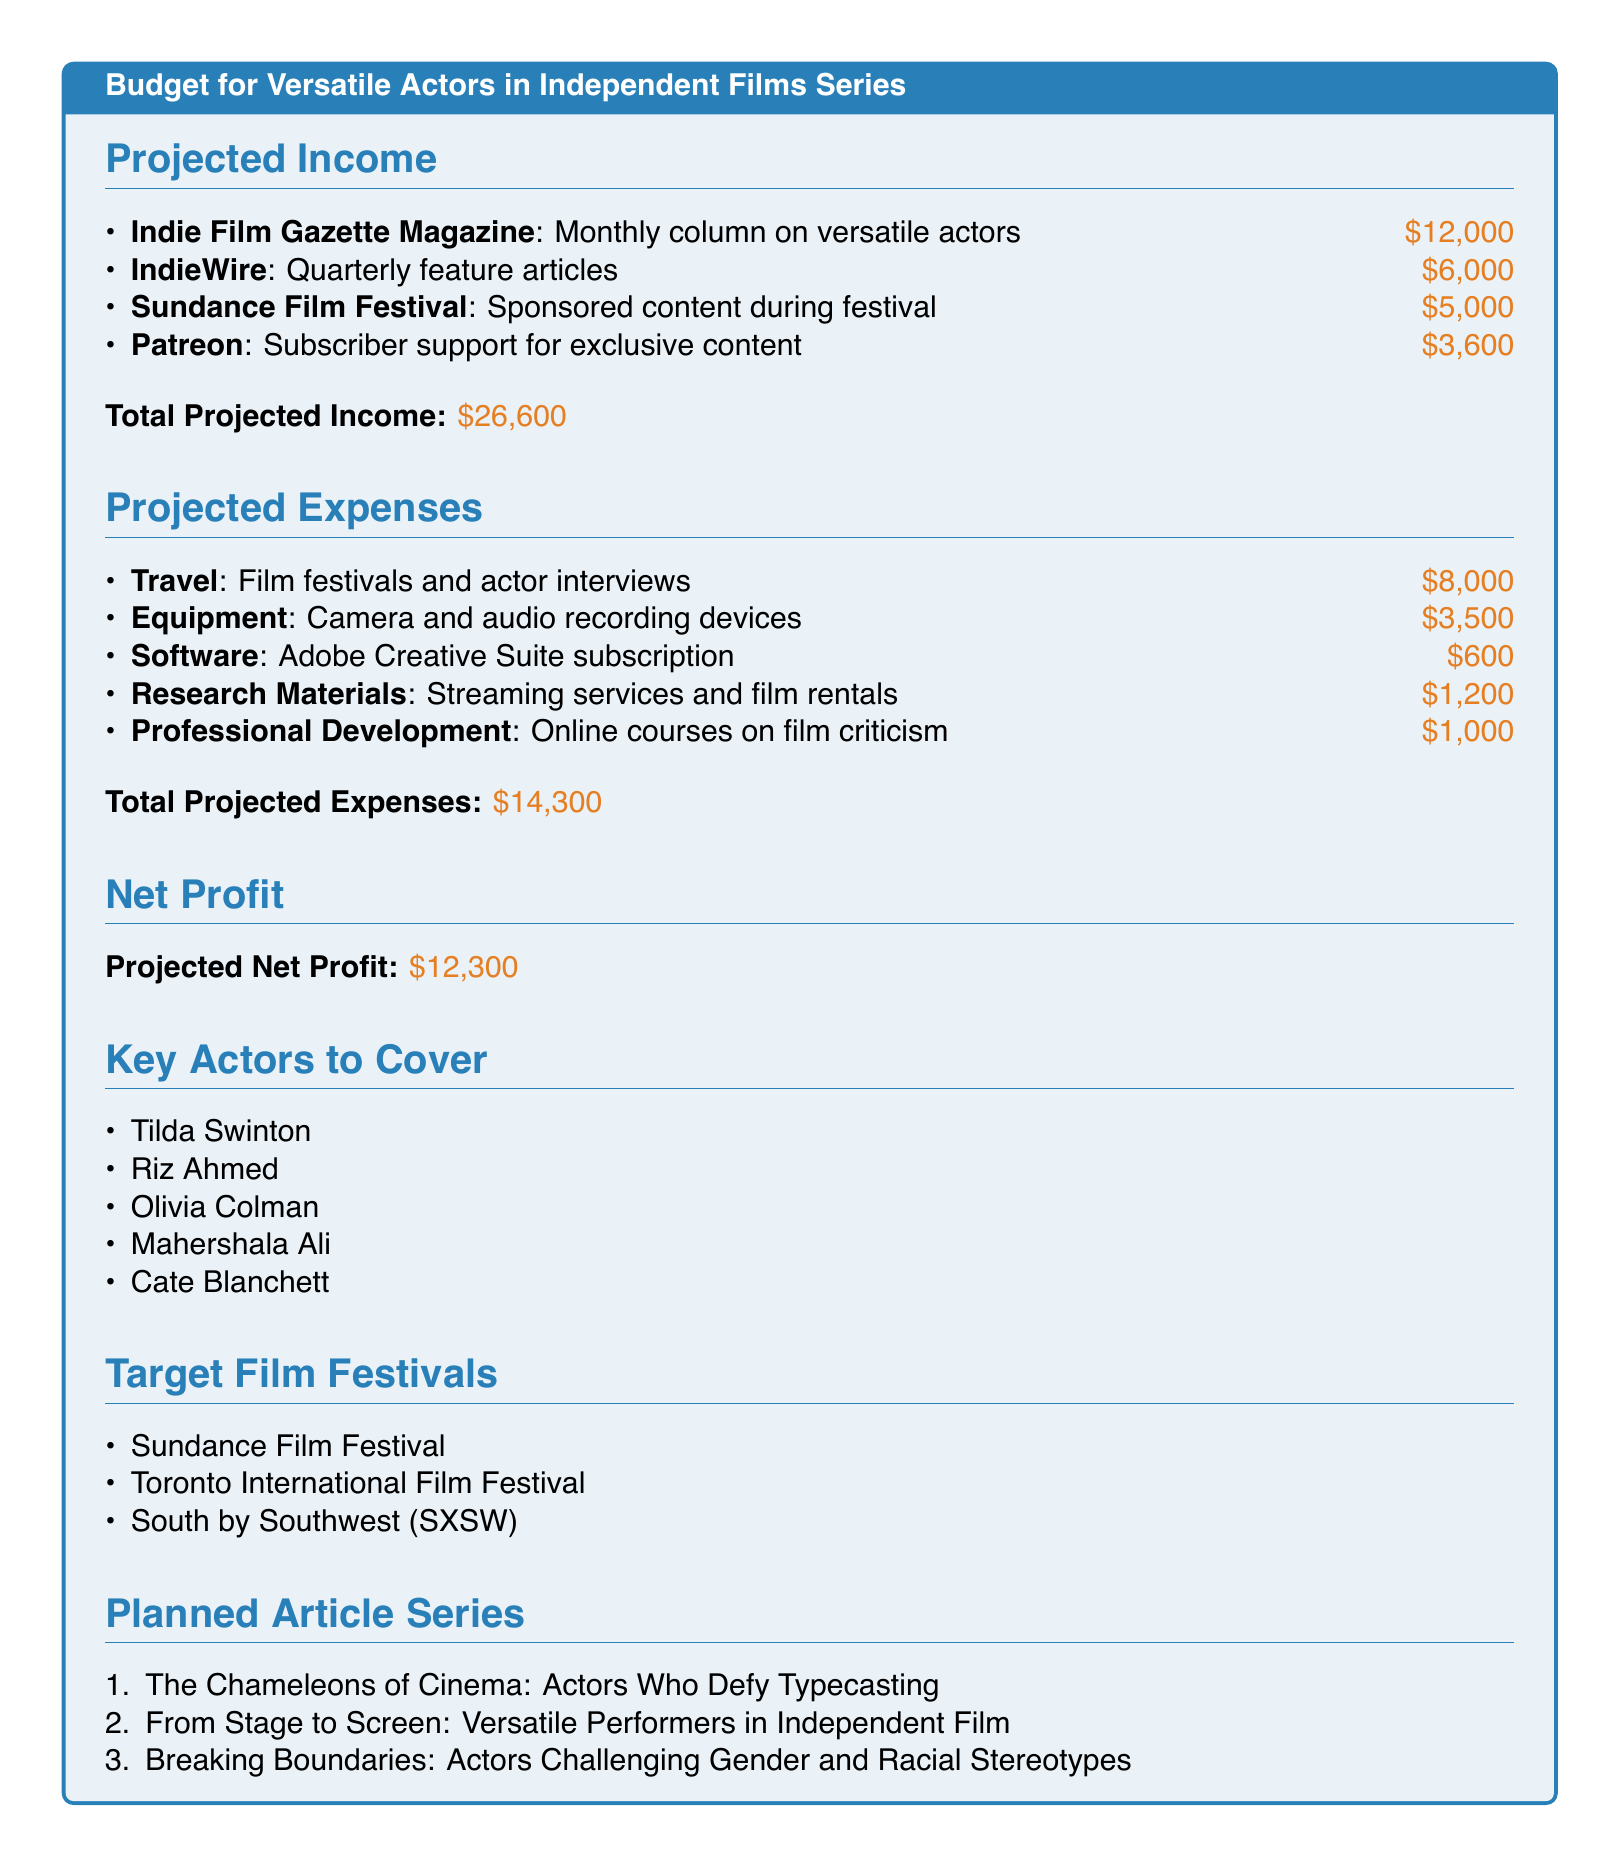What is the total projected income? The total projected income is the sum of all income sources, which is $12,000 + $6,000 + $5,000 + $3,600 = $26,600.
Answer: $26,600 What is the projected net profit? The projected net profit is calculated by subtracting total projected expenses from total projected income, which is $26,600 - $14,300.
Answer: $12,300 What is the budget for travel? The budget for travel in the projected expenses section is specified as $8,000 for film festivals and actor interviews.
Answer: $8,000 How many key actors are listed? The document lists a total of five key actors to cover in the series.
Answer: 5 Which film festival is mentioned for sponsored content? The Sundance Film Festival is mentioned in the projected income as a source for sponsored content.
Answer: Sundance Film Festival What is the total projected expenses? The total projected expenses is calculated by summing all expense categories, which is $8,000 + $3,500 + $600 + $1,200 + $1,000 = $14,300.
Answer: $14,300 What is one of the planned article series titles? One of the planned article series titles is "The Chameleons of Cinema: Actors Who Defy Typecasting."
Answer: The Chameleons of Cinema: Actors Who Defy Typecasting How many target film festivals are listed? The document lists three target film festivals for the series.
Answer: 3 What is the budget for professional development? The budget allocated for professional development in projected expenses is $1,000 for online courses on film criticism.
Answer: $1,000 